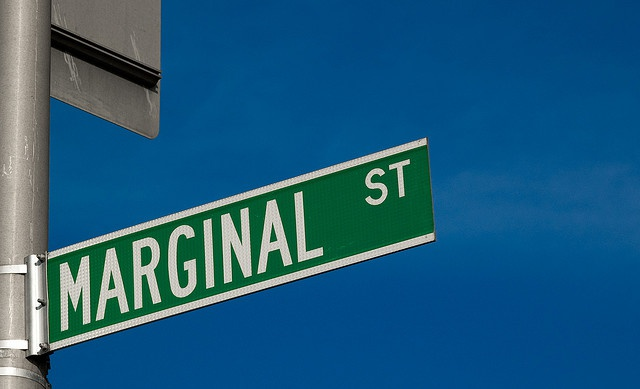Describe the objects in this image and their specific colors. I can see various objects in this image with different colors. 